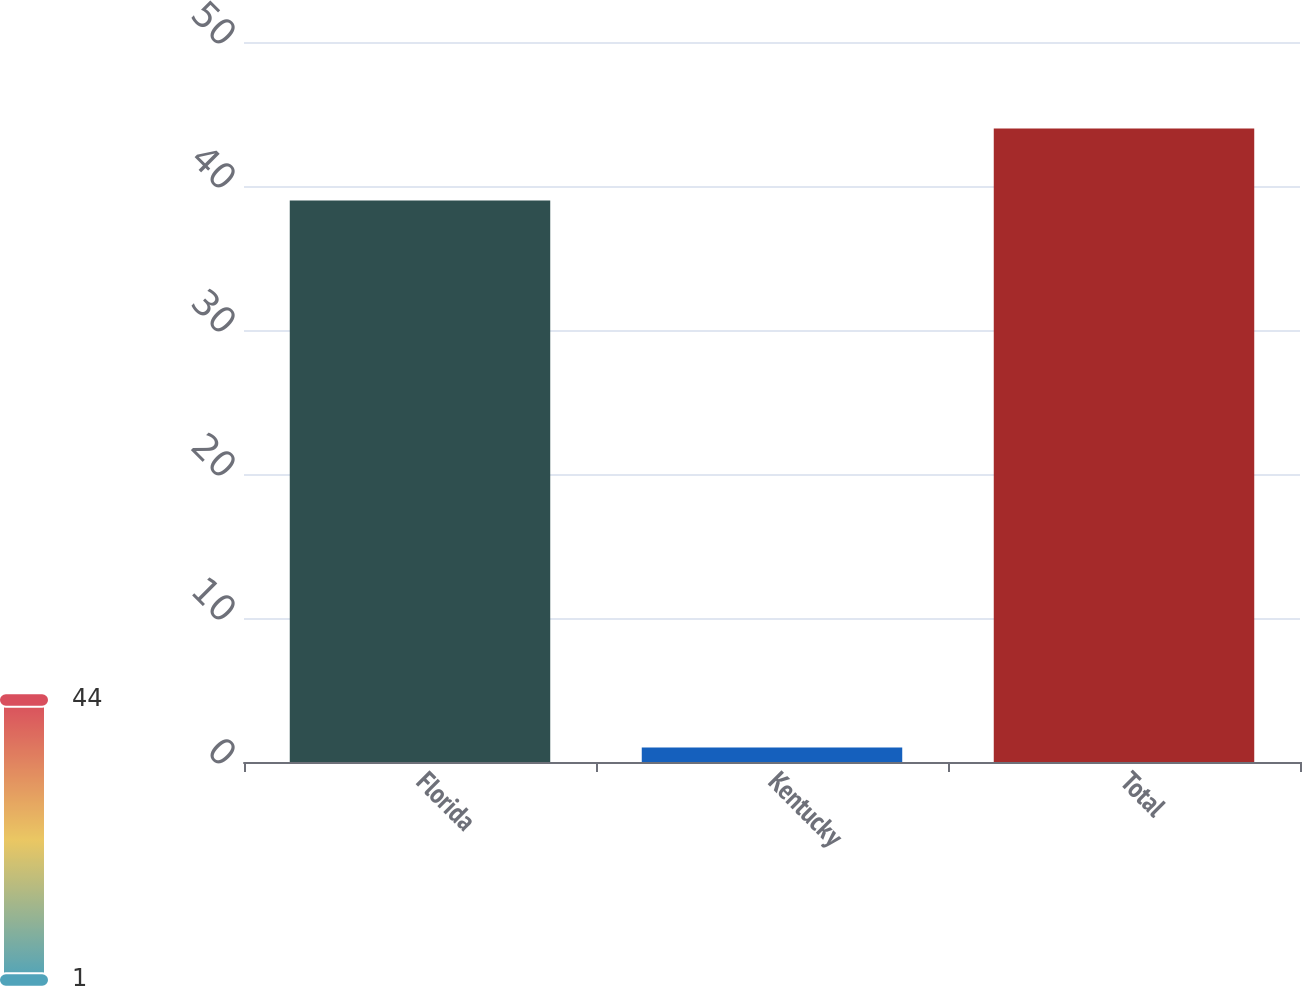Convert chart. <chart><loc_0><loc_0><loc_500><loc_500><bar_chart><fcel>Florida<fcel>Kentucky<fcel>Total<nl><fcel>39<fcel>1<fcel>44<nl></chart> 